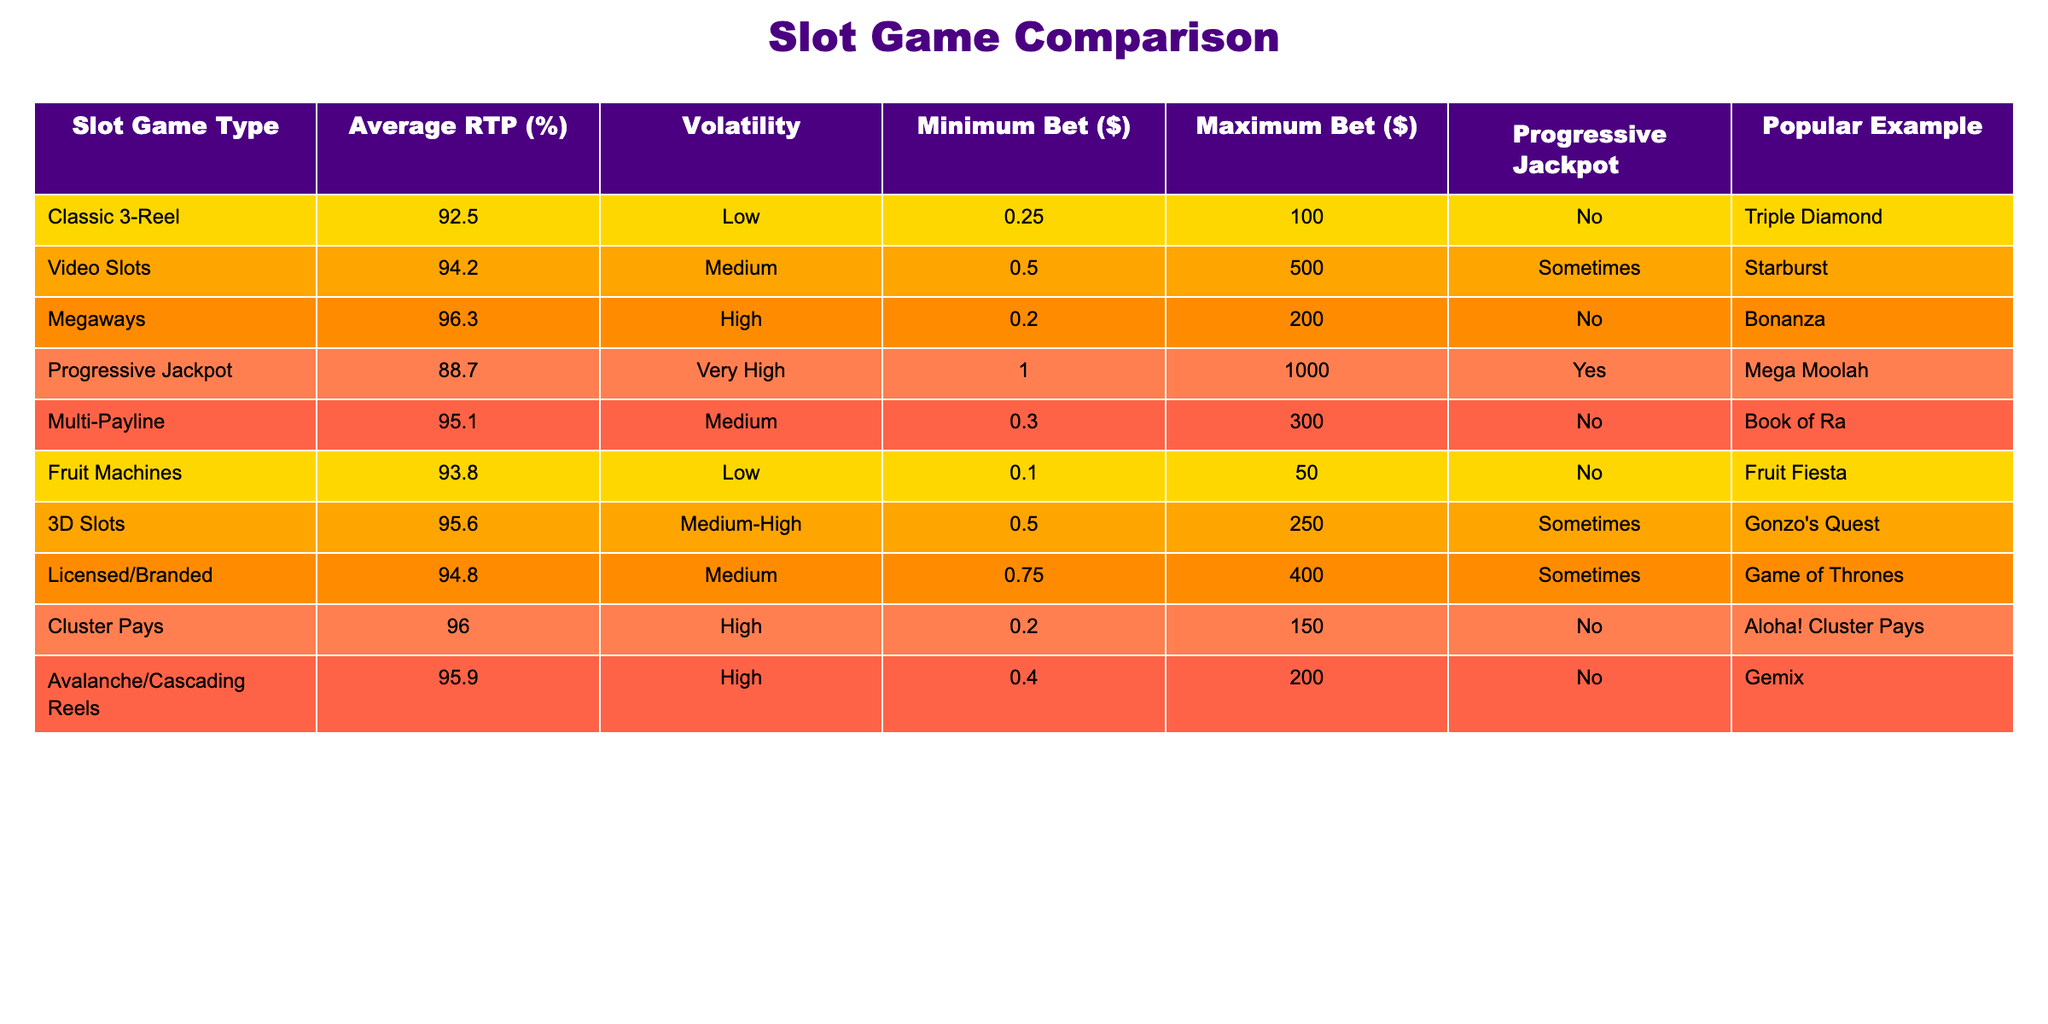What is the average RTP of Classic 3-Reel slots? The table shows the Average RTP for Classic 3-Reel slots listed as 92.5%. Therefore, the answer is directly from the table.
Answer: 92.5% Which slot game type has the highest average RTP? By examining the Average RTP column, Megaways has the highest value at 96.3%, more than any other slot game type listed in the table.
Answer: Megaways Is the Progressive Jackpot slot game type associated with a progressive jackpot? The table indicates the Progressive Jackpot slot game type does have a progressive jackpot, marked as 'Yes' under the Progressive Jackpot column.
Answer: Yes Which slot type has the lowest minimum bet requirement? Looking at the Minimum Bet column, Fruit Machines have the lowest minimum bet at $0.10 compared to the other slot types.
Answer: Fruit Machines Calculate the average maximum bet of the slot game types listed. First, extract the Maximum Bet values: 100, 500, 200, 1000, 300, 50, 250, 400, 150, 200. The total is 3000 and there are 10 types. Dividing gives an average of 3000/10 = 300.
Answer: 300 Which slot game type has both high volatility and a progressive jackpot? By inspecting the table, the Progressive Jackpot slot game type is categorized as 'Very High' volatility and is also marked 'Yes' for having a progressive jackpot. This is the only type that meets both criteria.
Answer: Progressive Jackpot Do all slot game types with high volatility have a minimum bet of at least $0.50? By analyzing the Minimum Bet column, the Megaways slot type with high volatility has a minimum bet of $0.20, which shows not all high volatility types meet that requirement.
Answer: No List one popular example of a Multi-Payline slot. The table provides 'Book of Ra' as a popular example under the Multi-Payline slot game type. This information is straightforward from the table provided.
Answer: Book of Ra What is the difference in average RTP between Video Slots and 3D Slots? The RTP for Video Slots is 94.2% and for 3D Slots it is 95.6%. Calculating the difference: 95.6 - 94.2 = 1.4. Therefore, the difference in average RTP is 1.4%.
Answer: 1.4% 